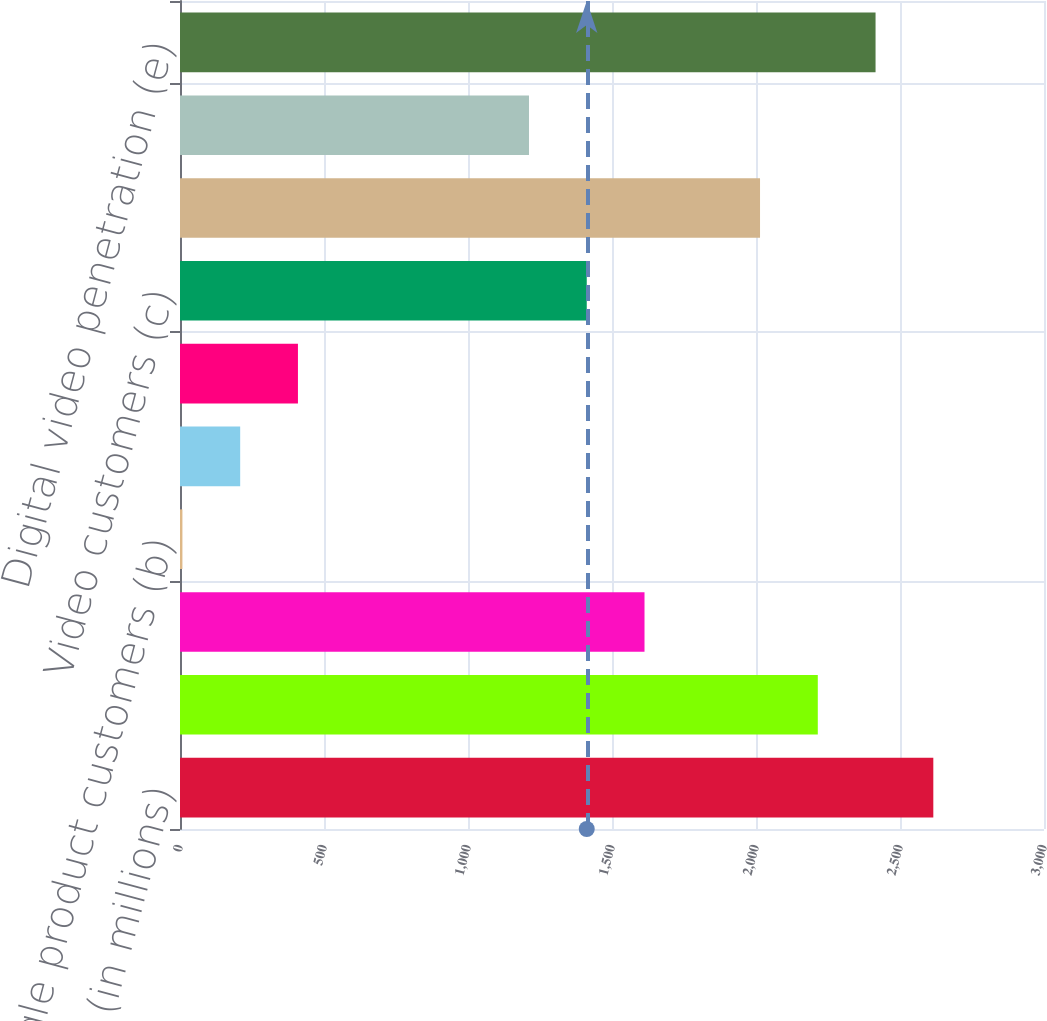<chart> <loc_0><loc_0><loc_500><loc_500><bar_chart><fcel>December 31 (in millions)<fcel>Homes and businesses passed<fcel>Total customer relationships<fcel>Single product customers (b)<fcel>Double product customers (b)<fcel>Triple product customers (b)<fcel>Video customers (c)<fcel>Video penetration (d)<fcel>Digital video customers (e)<fcel>Digital video penetration (e)<nl><fcel>2615.68<fcel>2214.56<fcel>1612.88<fcel>8.4<fcel>208.96<fcel>409.52<fcel>1412.32<fcel>2014<fcel>1211.76<fcel>2415.12<nl></chart> 